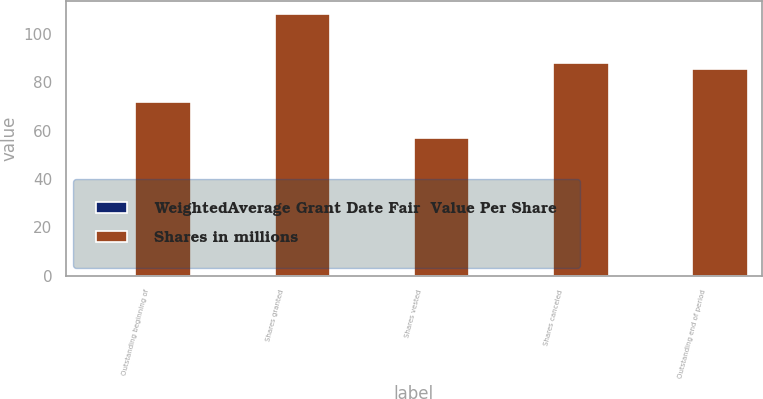Convert chart. <chart><loc_0><loc_0><loc_500><loc_500><stacked_bar_chart><ecel><fcel>Outstanding beginning of<fcel>Shares granted<fcel>Shares vested<fcel>Shares canceled<fcel>Outstanding end of period<nl><fcel>WeightedAverage Grant Date Fair  Value Per Share<fcel>0.24<fcel>0.09<fcel>0.04<fcel>0.01<fcel>0.28<nl><fcel>Shares in millions<fcel>71.99<fcel>108.36<fcel>56.93<fcel>87.99<fcel>85.67<nl></chart> 